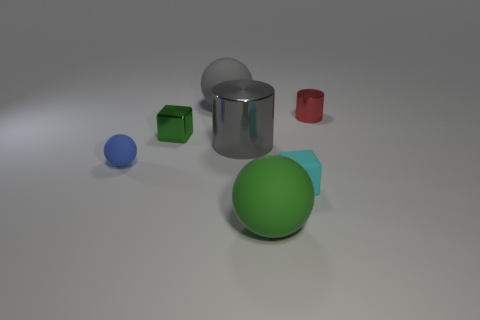How many big objects have the same material as the small cylinder?
Your answer should be very brief. 1. There is a gray sphere; what number of gray rubber spheres are on the left side of it?
Keep it short and to the point. 0. Is the material of the tiny block that is left of the big gray metal cylinder the same as the tiny object right of the small cyan matte thing?
Your answer should be very brief. Yes. Are there more objects that are on the left side of the small red metal cylinder than matte spheres that are in front of the blue rubber object?
Give a very brief answer. Yes. What is the material of the big sphere that is the same color as the large metallic thing?
Offer a very short reply. Rubber. Is there anything else that has the same shape as the cyan rubber object?
Ensure brevity in your answer.  Yes. There is a tiny object that is both behind the big cylinder and left of the tiny red metallic thing; what material is it made of?
Give a very brief answer. Metal. Is the material of the small green object the same as the green object that is right of the large gray rubber sphere?
Ensure brevity in your answer.  No. Is there any other thing that has the same size as the red cylinder?
Make the answer very short. Yes. How many objects are either tiny red metallic objects or small metal things that are in front of the red metallic thing?
Give a very brief answer. 2. 